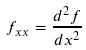<formula> <loc_0><loc_0><loc_500><loc_500>f _ { x x } = \frac { d ^ { 2 } f } { d x ^ { 2 } }</formula> 